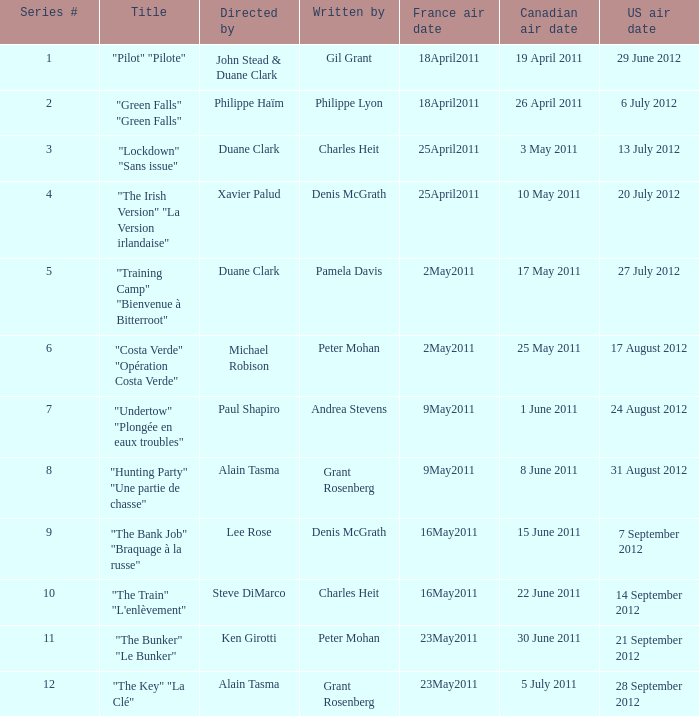What is the canadian airtime when the us airtime is 24 august 2012? 1 June 2011. 